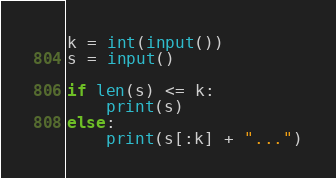<code> <loc_0><loc_0><loc_500><loc_500><_Python_>k = int(input())
s = input()

if len(s) <= k:
    print(s)
else:
    print(s[:k] + "...")
</code> 